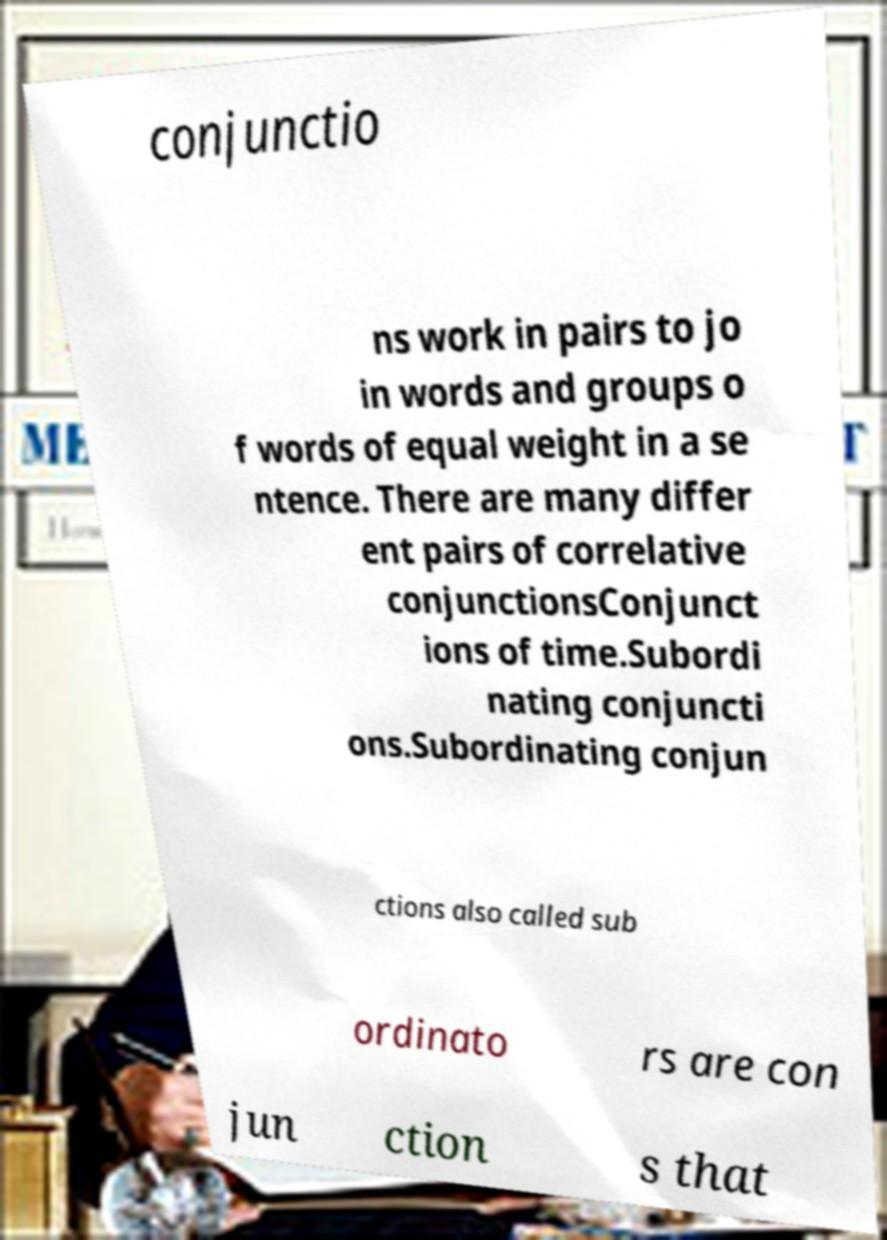Can you read and provide the text displayed in the image?This photo seems to have some interesting text. Can you extract and type it out for me? conjunctio ns work in pairs to jo in words and groups o f words of equal weight in a se ntence. There are many differ ent pairs of correlative conjunctionsConjunct ions of time.Subordi nating conjuncti ons.Subordinating conjun ctions also called sub ordinato rs are con jun ction s that 